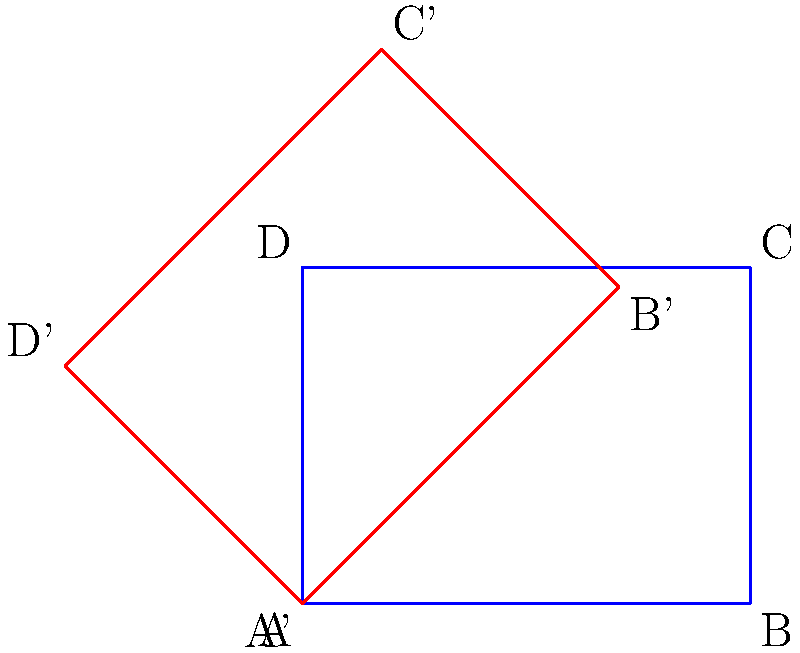The coach has decided to relocate practice sessions to a new field with a different orientation. To help visualize the change, you need to rotate the original field diagram by 45° clockwise. If the original field is represented by rectangle ABCD, what transformation would correctly describe the new field position (represented by A'B'C'D') in relation to the original? To solve this problem, let's follow these steps:

1. Observe the original field (blue rectangle ABCD) and the rotated field (red rectangle A'B'C'D').

2. Notice that the rotation is 45° clockwise. In mathematics, clockwise rotations are considered negative, while counterclockwise rotations are positive.

3. The transformation that describes this rotation can be expressed as a function R(θ), where θ is the angle of rotation.

4. Since the rotation is clockwise, we need to use a negative angle: R(-45°).

5. However, in transformational geometry, it's more common to express rotations as counterclockwise. To convert a clockwise rotation to counterclockwise, we can subtract it from 360°:

   360° - 45° = 315°

6. Therefore, the correct transformation to describe the new field position is a rotation of 315° counterclockwise around the origin, which can be written as R(315°).

This rotation transforms each point of the original field ABCD to its corresponding point on the new field A'B'C'D'.
Answer: R(315°) 